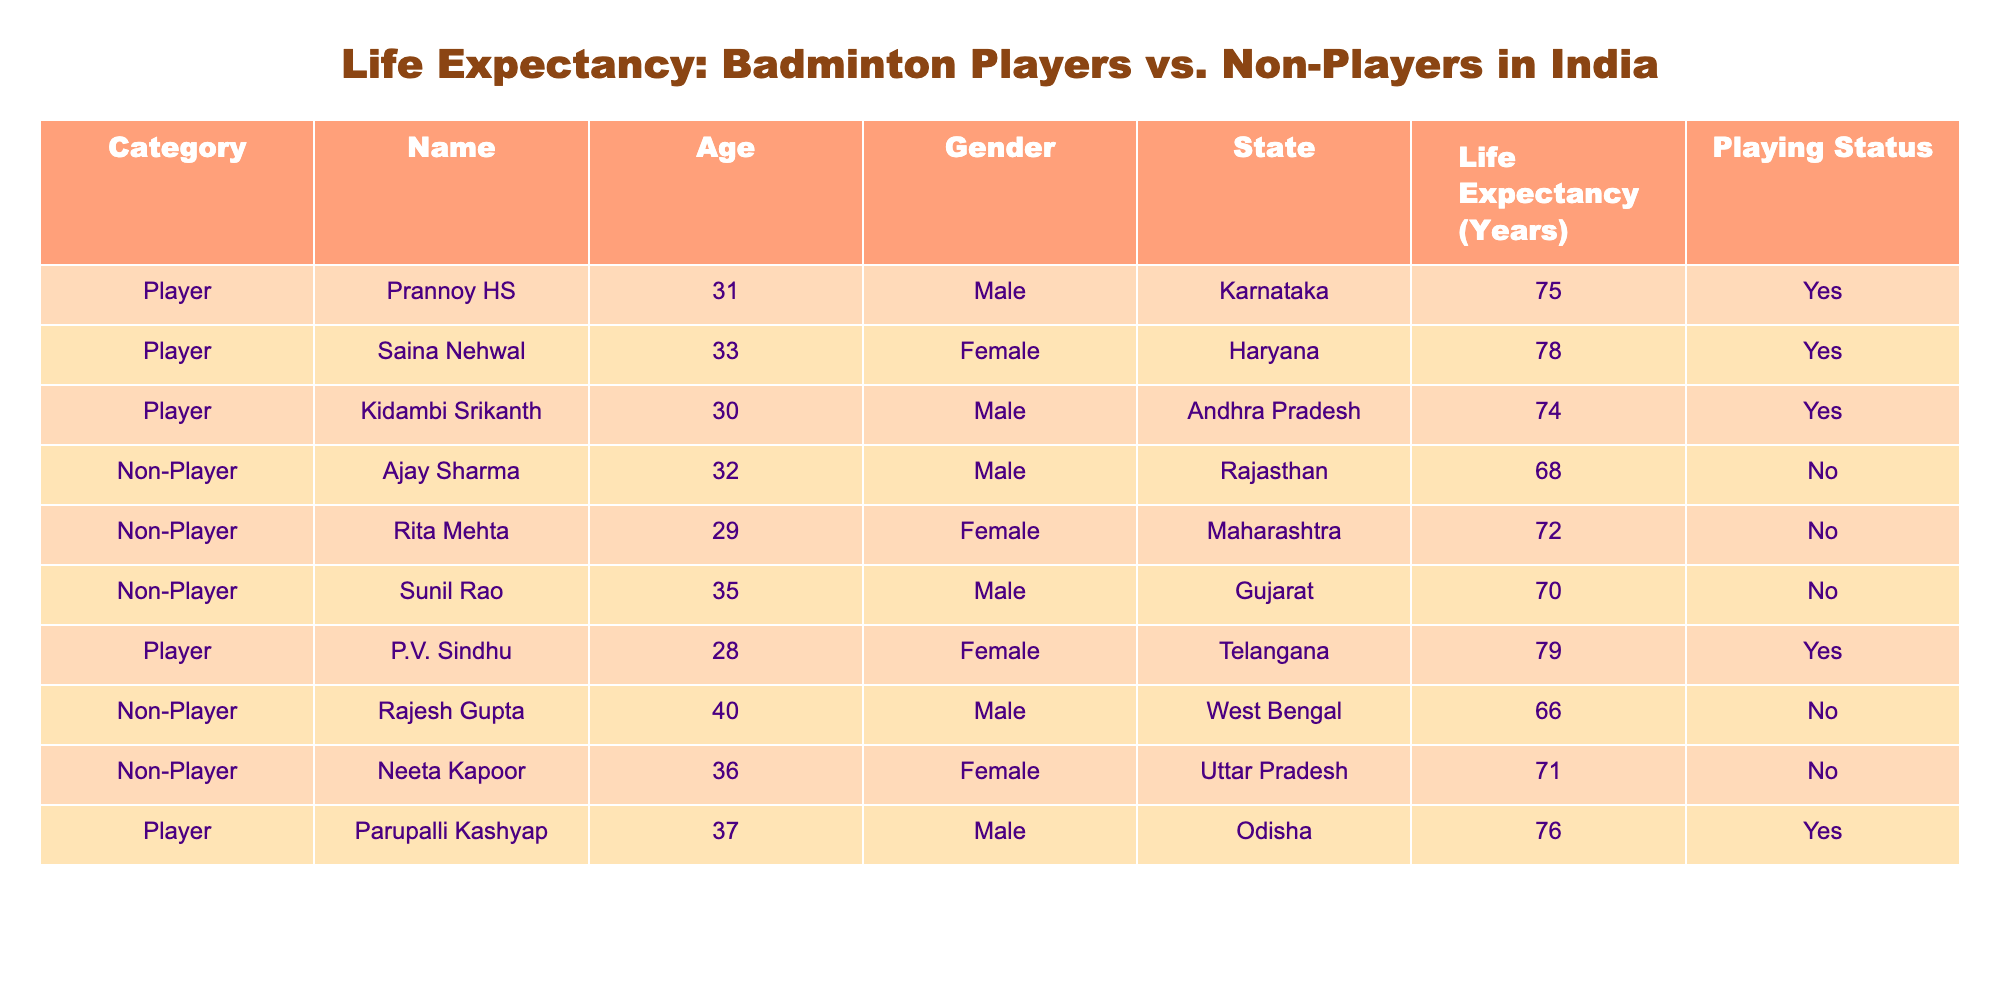What is the life expectancy of Saina Nehwal? Referring to the table, Saina Nehwal is listed as a player with a life expectancy of 78 years.
Answer: 78 How old is Prannoy HS? Looking at the table, Prannoy HS is noted to be 31 years old.
Answer: 31 What is the maximum life expectancy among the players? The table shows the life expectancy for all players: 75 (Prannoy HS), 78 (Saina Nehwal), 74 (Kidambi Srikanth), 79 (P.V. Sindhu), and 76 (Parupalli Kashyap). The maximum is 79 years for P.V. Sindhu.
Answer: 79 How many non-players have a life expectancy greater than 70 years? The non-players listed are Ajay Sharma (68), Rita Mehta (72), Sunil Rao (70), Rajesh Gupta (66), and Neeta Kapoor (71). The ones with life expectancies greater than 70 are Rita Mehta (72) and Neeta Kapoor (71), leading to a count of 2.
Answer: 2 Is the life expectancy of players generally higher than that of non-players? Players have the following life expectancies: 75, 78, 74, 79, and 76, averaging to (75 + 78 + 74 + 79 + 76) / 5 = 76. The non-players have: 68, 72, 70, 66, and 71, averaging to (68 + 72 + 70 + 66 + 71) / 5 = 67.4. Comparing both, the average life expectancy for players (76) is indeed higher than for non-players (67.4).
Answer: Yes Which gender has the highest life expectancy among players? From the table, the female players are Saina Nehwal (78) and P.V. Sindhu (79), while the male players have Prannoy HS (75), Kidambi Srikanth (74), and Parupalli Kashyap (76). The highest life expectancy is for P.V. Sindhu (79), which is among female players.
Answer: Female What is the average life expectancy of all individuals in the table? To find the average, we sum all life expectancies: (75 + 78 + 74 + 68 + 72 + 70 + 66 + 71 + 79 + 76) = 790, and since there are 10 individuals, the average is 790 / 10 = 79.
Answer: 79 Are there more male or female players listed in the table? Reviewing the players, we see there are 3 males (Prannoy HS, Kidambi Srikanth, Parupalli Kashyap) and 2 females (Saina Nehwal, P.V. Sindhu). Thus, there are more male players.
Answer: Male 